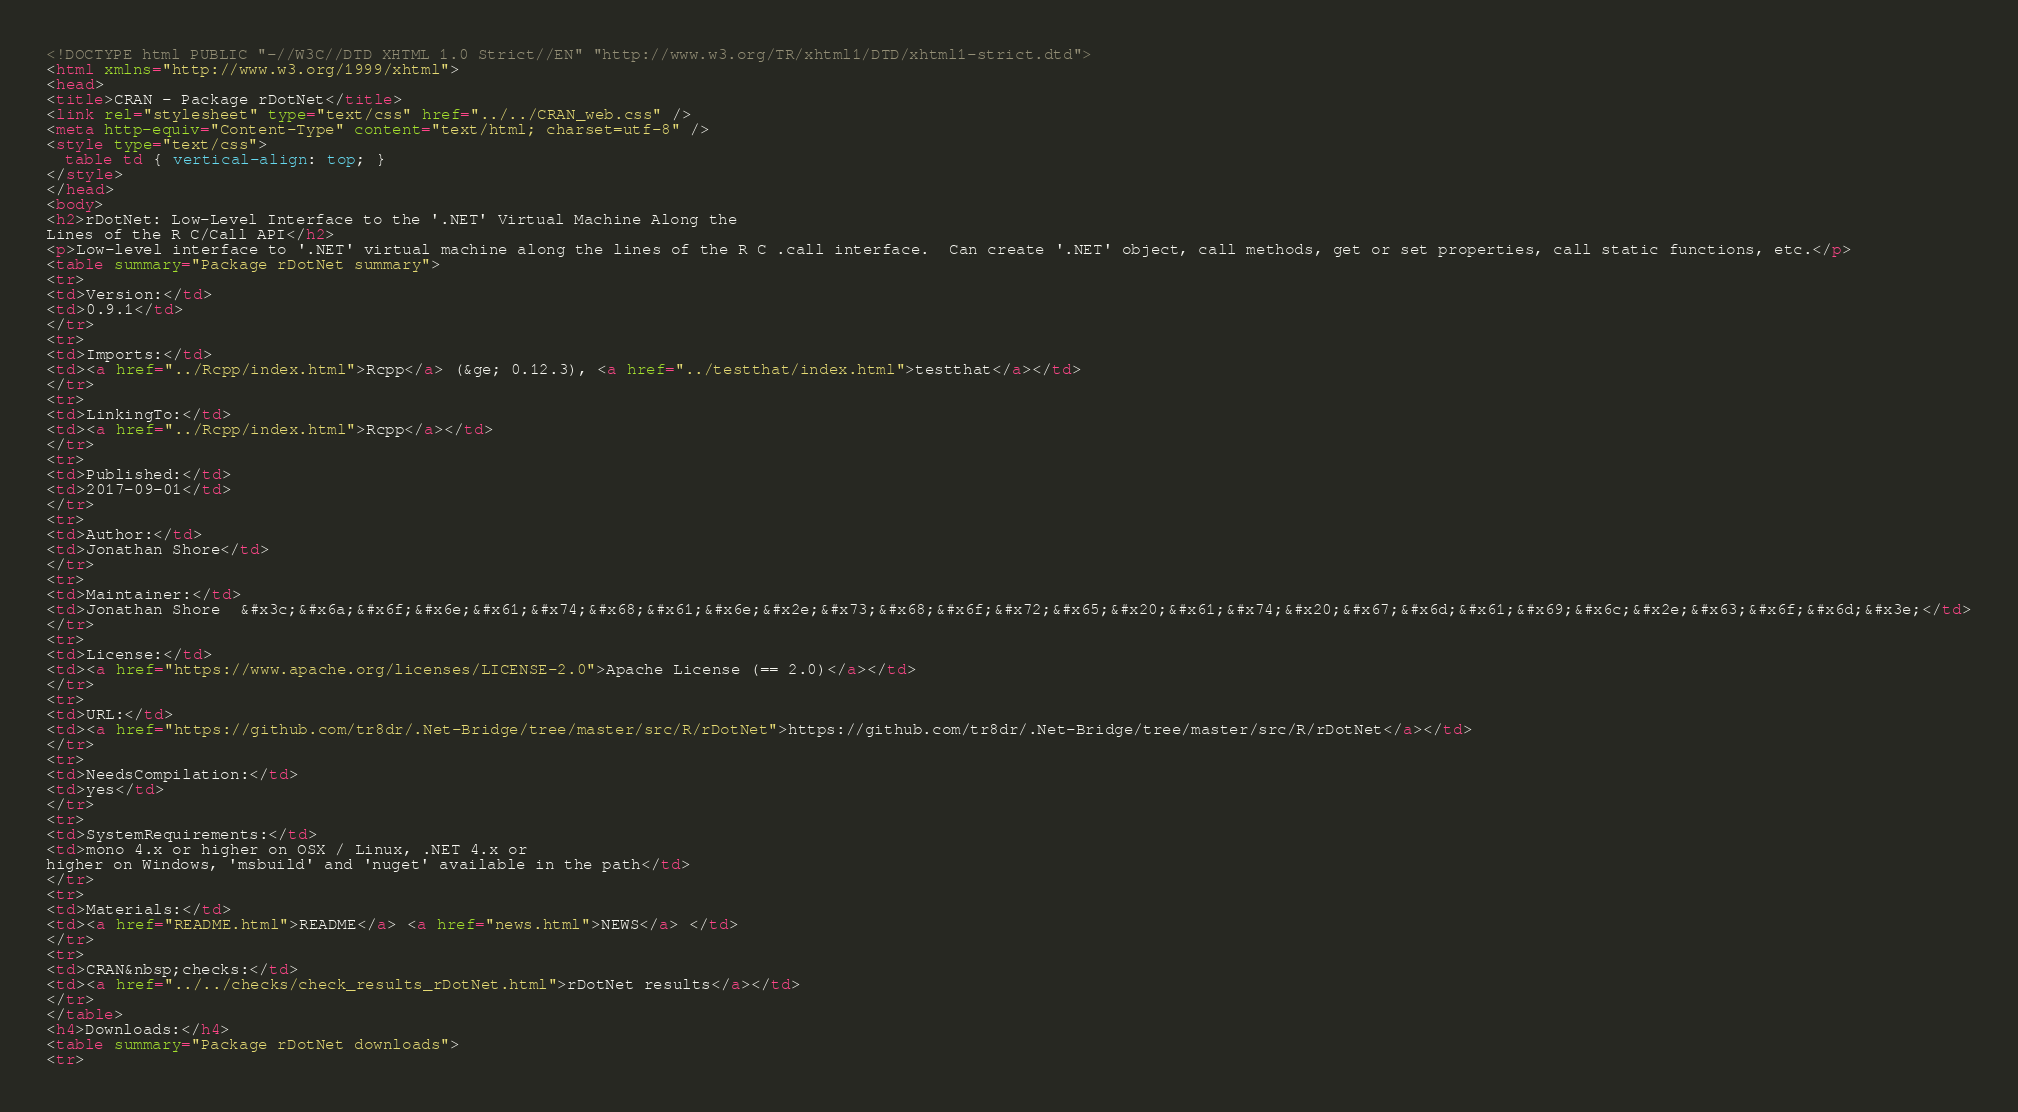<code> <loc_0><loc_0><loc_500><loc_500><_HTML_><!DOCTYPE html PUBLIC "-//W3C//DTD XHTML 1.0 Strict//EN" "http://www.w3.org/TR/xhtml1/DTD/xhtml1-strict.dtd">
<html xmlns="http://www.w3.org/1999/xhtml">
<head>
<title>CRAN - Package rDotNet</title>
<link rel="stylesheet" type="text/css" href="../../CRAN_web.css" />
<meta http-equiv="Content-Type" content="text/html; charset=utf-8" />
<style type="text/css">
  table td { vertical-align: top; }
</style>
</head>
<body>
<h2>rDotNet: Low-Level Interface to the '.NET' Virtual Machine Along the
Lines of the R C/Call API</h2>
<p>Low-level interface to '.NET' virtual machine along the lines of the R C .call interface.  Can create '.NET' object, call methods, get or set properties, call static functions, etc.</p>
<table summary="Package rDotNet summary">
<tr>
<td>Version:</td>
<td>0.9.1</td>
</tr>
<tr>
<td>Imports:</td>
<td><a href="../Rcpp/index.html">Rcpp</a> (&ge; 0.12.3), <a href="../testthat/index.html">testthat</a></td>
</tr>
<tr>
<td>LinkingTo:</td>
<td><a href="../Rcpp/index.html">Rcpp</a></td>
</tr>
<tr>
<td>Published:</td>
<td>2017-09-01</td>
</tr>
<tr>
<td>Author:</td>
<td>Jonathan Shore</td>
</tr>
<tr>
<td>Maintainer:</td>
<td>Jonathan Shore  &#x3c;&#x6a;&#x6f;&#x6e;&#x61;&#x74;&#x68;&#x61;&#x6e;&#x2e;&#x73;&#x68;&#x6f;&#x72;&#x65;&#x20;&#x61;&#x74;&#x20;&#x67;&#x6d;&#x61;&#x69;&#x6c;&#x2e;&#x63;&#x6f;&#x6d;&#x3e;</td>
</tr>
<tr>
<td>License:</td>
<td><a href="https://www.apache.org/licenses/LICENSE-2.0">Apache License (== 2.0)</a></td>
</tr>
<tr>
<td>URL:</td>
<td><a href="https://github.com/tr8dr/.Net-Bridge/tree/master/src/R/rDotNet">https://github.com/tr8dr/.Net-Bridge/tree/master/src/R/rDotNet</a></td>
</tr>
<tr>
<td>NeedsCompilation:</td>
<td>yes</td>
</tr>
<tr>
<td>SystemRequirements:</td>
<td>mono 4.x or higher on OSX / Linux, .NET 4.x or
higher on Windows, 'msbuild' and 'nuget' available in the path</td>
</tr>
<tr>
<td>Materials:</td>
<td><a href="README.html">README</a> <a href="news.html">NEWS</a> </td>
</tr>
<tr>
<td>CRAN&nbsp;checks:</td>
<td><a href="../../checks/check_results_rDotNet.html">rDotNet results</a></td>
</tr>
</table>
<h4>Downloads:</h4>
<table summary="Package rDotNet downloads">
<tr></code> 